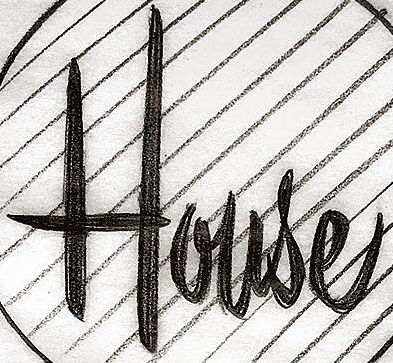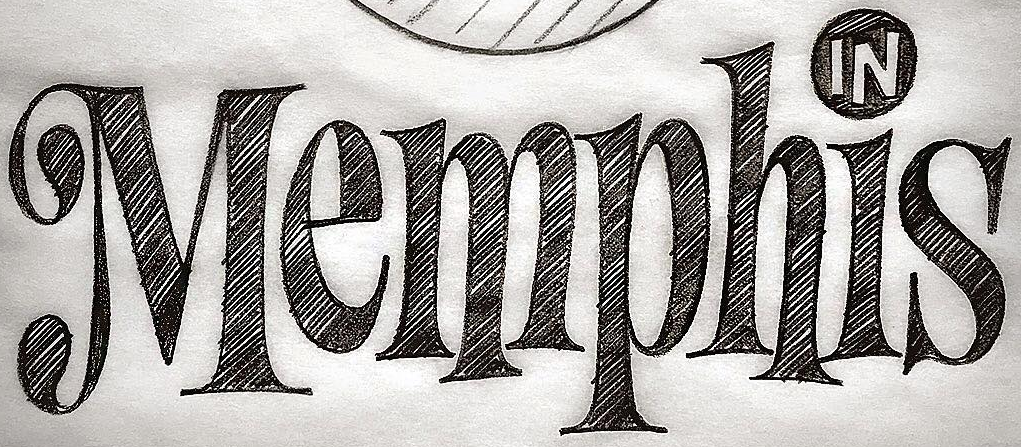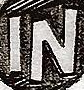Read the text content from these images in order, separated by a semicolon. House; Memphis; IN 